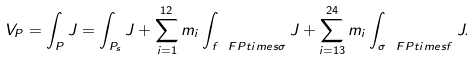Convert formula to latex. <formula><loc_0><loc_0><loc_500><loc_500>V _ { P } = \int _ { P } J = \int _ { P _ { s } } J + \sum _ { i = 1 } ^ { 1 2 } m _ { i } \int _ { f \ F P t i m e s \sigma } J + \sum _ { i = 1 3 } ^ { 2 4 } m _ { i } \int _ { \sigma \ F P t i m e s f } J .</formula> 